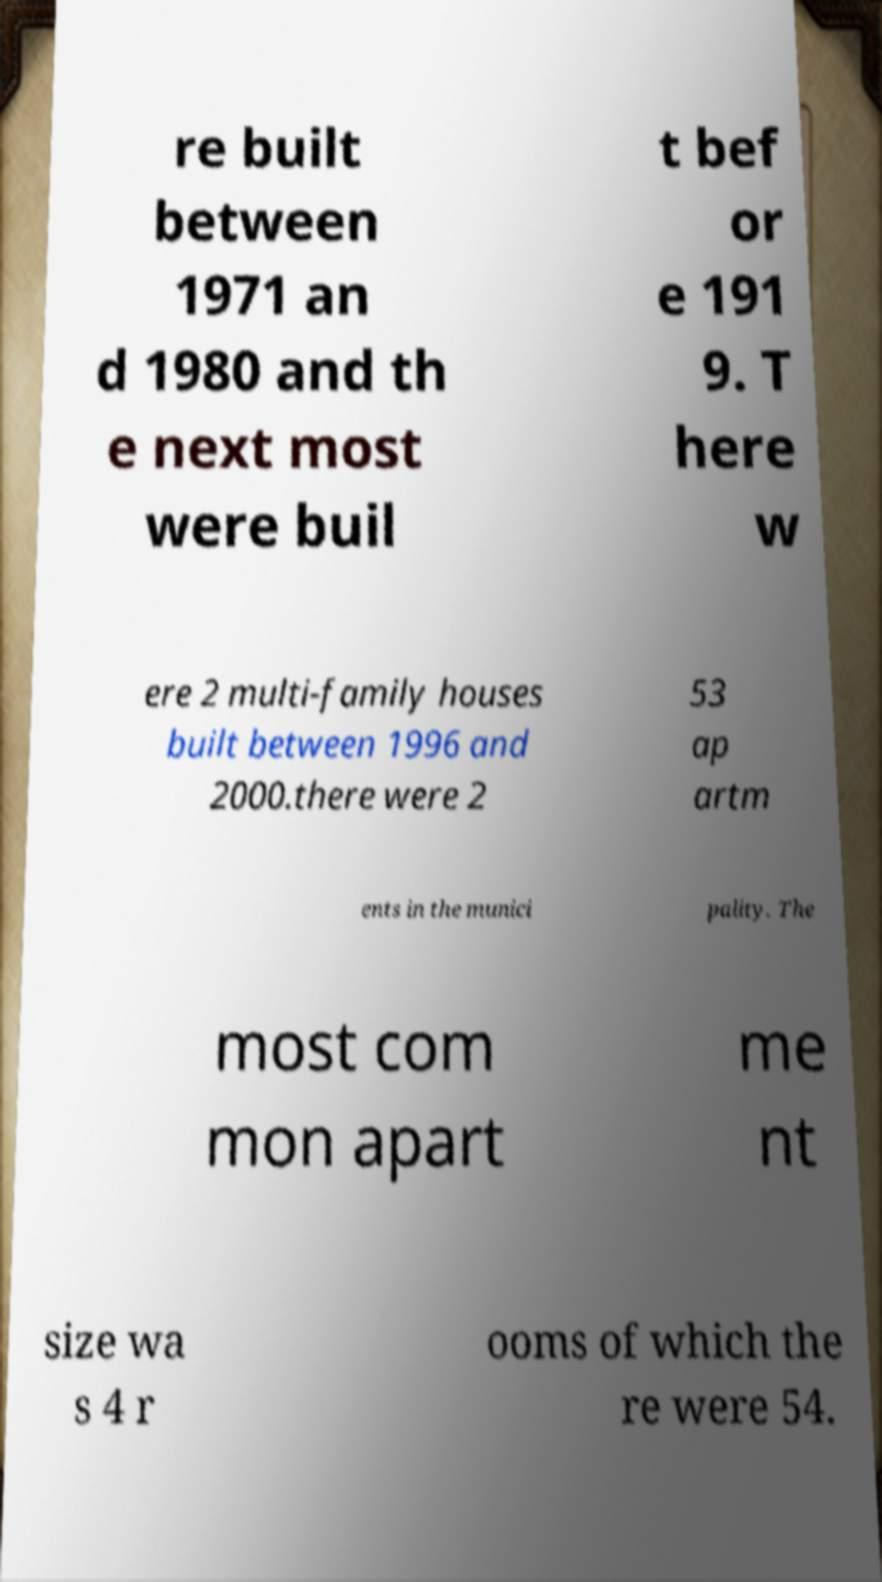Can you accurately transcribe the text from the provided image for me? re built between 1971 an d 1980 and th e next most were buil t bef or e 191 9. T here w ere 2 multi-family houses built between 1996 and 2000.there were 2 53 ap artm ents in the munici pality. The most com mon apart me nt size wa s 4 r ooms of which the re were 54. 